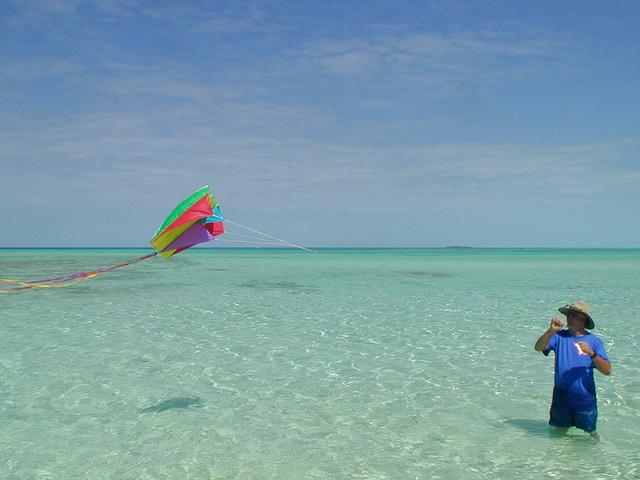Does this water look clear?
Keep it brief. Yes. What is the man doing?
Write a very short answer. Flying kite. Is there a kite in the water?
Give a very brief answer. No. Is the water blue?
Be succinct. Yes. 